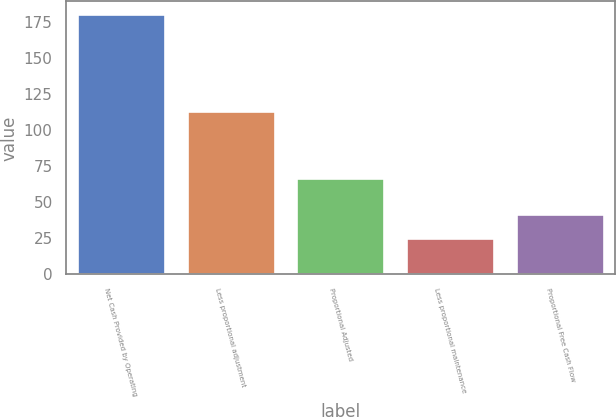Convert chart. <chart><loc_0><loc_0><loc_500><loc_500><bar_chart><fcel>Net Cash Provided by Operating<fcel>Less proportional adjustment<fcel>Proportional Adjusted<fcel>Less proportional maintenance<fcel>Proportional Free Cash Flow<nl><fcel>180<fcel>113<fcel>67<fcel>25<fcel>42<nl></chart> 